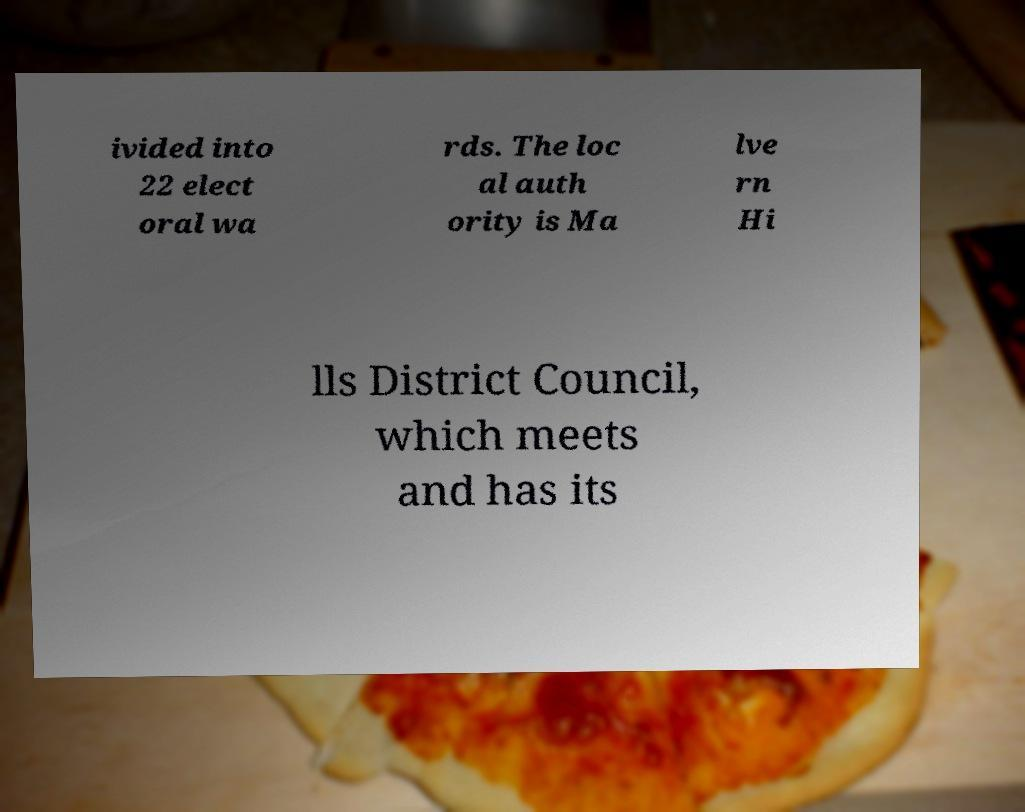There's text embedded in this image that I need extracted. Can you transcribe it verbatim? ivided into 22 elect oral wa rds. The loc al auth ority is Ma lve rn Hi lls District Council, which meets and has its 